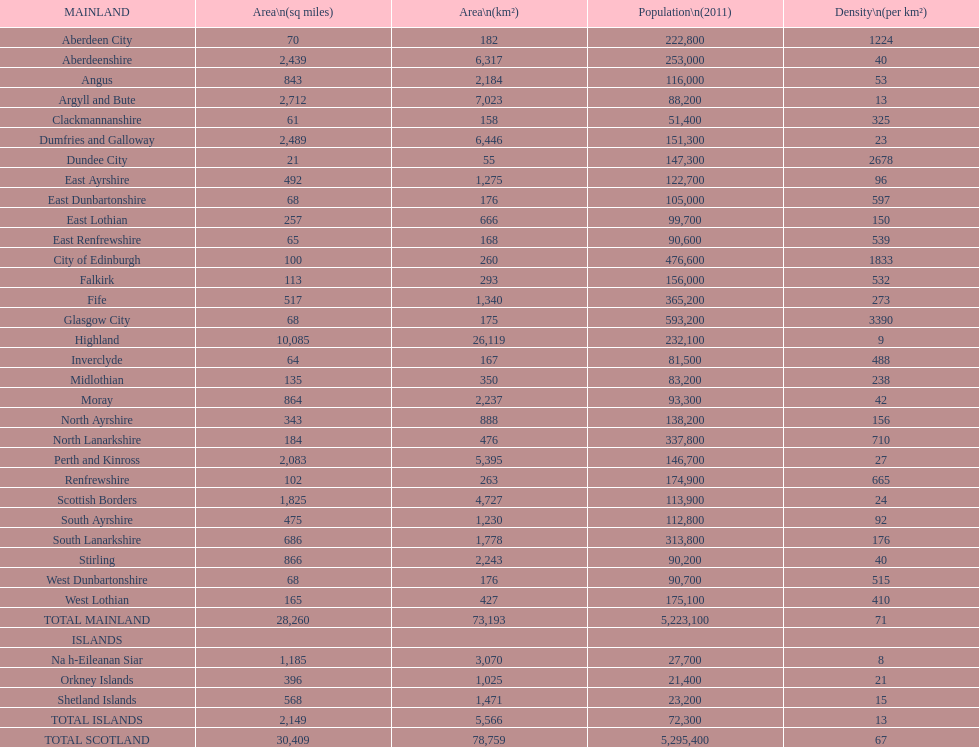How many primary landmasses have populations less than 100,000? 9. 